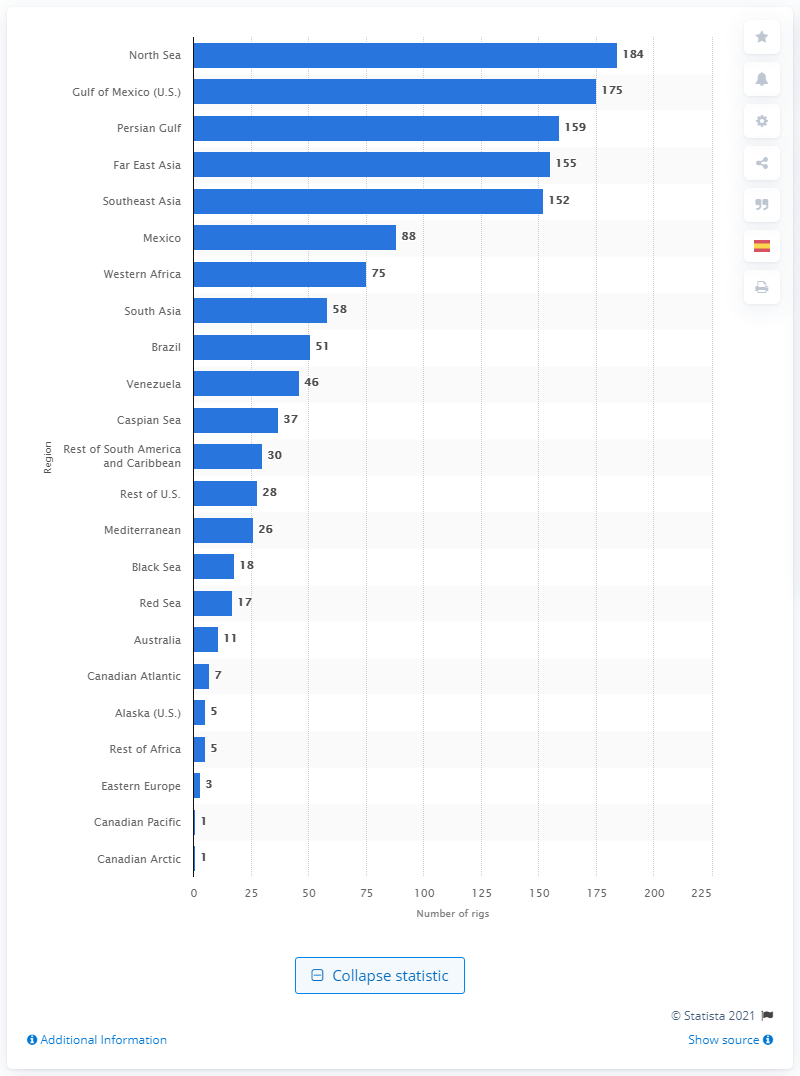Mention a couple of crucial points in this snapshot. There were 184 offshore rigs in the North Sea in January 2018. 